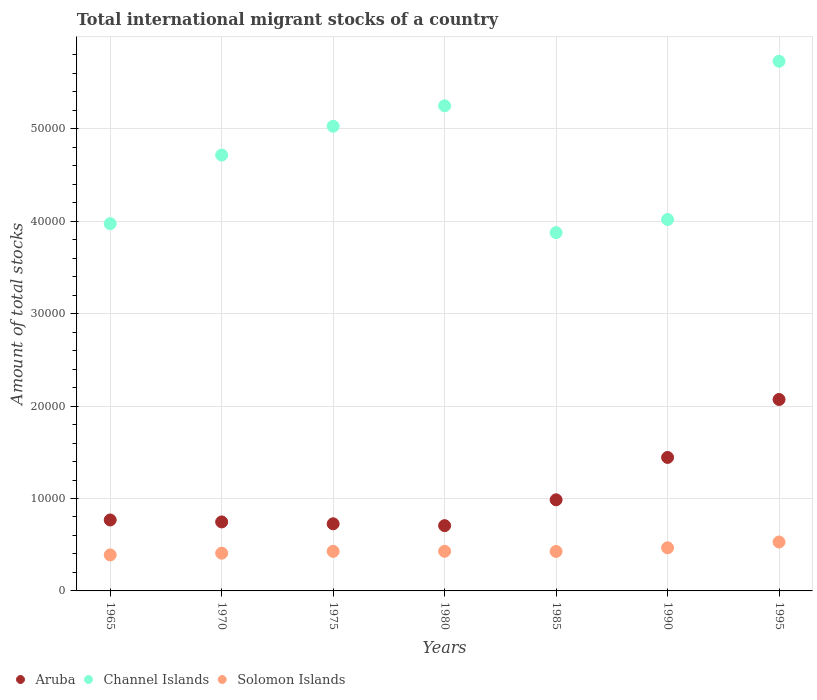How many different coloured dotlines are there?
Keep it short and to the point. 3. What is the amount of total stocks in in Solomon Islands in 1995?
Ensure brevity in your answer.  5293. Across all years, what is the maximum amount of total stocks in in Solomon Islands?
Offer a very short reply. 5293. Across all years, what is the minimum amount of total stocks in in Aruba?
Give a very brief answer. 7063. What is the total amount of total stocks in in Aruba in the graph?
Ensure brevity in your answer.  7.45e+04. What is the difference between the amount of total stocks in in Aruba in 1970 and that in 1990?
Ensure brevity in your answer.  -6978. What is the difference between the amount of total stocks in in Solomon Islands in 1990 and the amount of total stocks in in Aruba in 1965?
Ensure brevity in your answer.  -3009. What is the average amount of total stocks in in Solomon Islands per year?
Provide a short and direct response. 4397.29. In the year 1975, what is the difference between the amount of total stocks in in Aruba and amount of total stocks in in Solomon Islands?
Your answer should be compact. 2980. What is the ratio of the amount of total stocks in in Channel Islands in 1975 to that in 1985?
Offer a very short reply. 1.3. What is the difference between the highest and the second highest amount of total stocks in in Aruba?
Your answer should be very brief. 6271. What is the difference between the highest and the lowest amount of total stocks in in Solomon Islands?
Keep it short and to the point. 1398. In how many years, is the amount of total stocks in in Channel Islands greater than the average amount of total stocks in in Channel Islands taken over all years?
Your answer should be compact. 4. Does the amount of total stocks in in Channel Islands monotonically increase over the years?
Your answer should be very brief. No. Is the amount of total stocks in in Aruba strictly greater than the amount of total stocks in in Solomon Islands over the years?
Give a very brief answer. Yes. How many dotlines are there?
Make the answer very short. 3. Are the values on the major ticks of Y-axis written in scientific E-notation?
Provide a succinct answer. No. Where does the legend appear in the graph?
Your answer should be very brief. Bottom left. How many legend labels are there?
Ensure brevity in your answer.  3. What is the title of the graph?
Offer a very short reply. Total international migrant stocks of a country. Does "South Sudan" appear as one of the legend labels in the graph?
Your answer should be very brief. No. What is the label or title of the X-axis?
Provide a short and direct response. Years. What is the label or title of the Y-axis?
Offer a terse response. Amount of total stocks. What is the Amount of total stocks of Aruba in 1965?
Your answer should be very brief. 7677. What is the Amount of total stocks in Channel Islands in 1965?
Your answer should be compact. 3.97e+04. What is the Amount of total stocks of Solomon Islands in 1965?
Offer a very short reply. 3895. What is the Amount of total stocks in Aruba in 1970?
Offer a very short reply. 7466. What is the Amount of total stocks of Channel Islands in 1970?
Ensure brevity in your answer.  4.72e+04. What is the Amount of total stocks of Solomon Islands in 1970?
Offer a terse response. 4084. What is the Amount of total stocks in Aruba in 1975?
Give a very brief answer. 7262. What is the Amount of total stocks in Channel Islands in 1975?
Make the answer very short. 5.03e+04. What is the Amount of total stocks of Solomon Islands in 1975?
Provide a succinct answer. 4282. What is the Amount of total stocks of Aruba in 1980?
Give a very brief answer. 7063. What is the Amount of total stocks of Channel Islands in 1980?
Make the answer very short. 5.25e+04. What is the Amount of total stocks of Solomon Islands in 1980?
Make the answer very short. 4289. What is the Amount of total stocks of Aruba in 1985?
Make the answer very short. 9860. What is the Amount of total stocks in Channel Islands in 1985?
Give a very brief answer. 3.88e+04. What is the Amount of total stocks in Solomon Islands in 1985?
Offer a very short reply. 4270. What is the Amount of total stocks of Aruba in 1990?
Give a very brief answer. 1.44e+04. What is the Amount of total stocks in Channel Islands in 1990?
Keep it short and to the point. 4.02e+04. What is the Amount of total stocks of Solomon Islands in 1990?
Keep it short and to the point. 4668. What is the Amount of total stocks in Aruba in 1995?
Keep it short and to the point. 2.07e+04. What is the Amount of total stocks of Channel Islands in 1995?
Offer a terse response. 5.73e+04. What is the Amount of total stocks of Solomon Islands in 1995?
Offer a terse response. 5293. Across all years, what is the maximum Amount of total stocks in Aruba?
Give a very brief answer. 2.07e+04. Across all years, what is the maximum Amount of total stocks in Channel Islands?
Make the answer very short. 5.73e+04. Across all years, what is the maximum Amount of total stocks in Solomon Islands?
Give a very brief answer. 5293. Across all years, what is the minimum Amount of total stocks in Aruba?
Offer a terse response. 7063. Across all years, what is the minimum Amount of total stocks in Channel Islands?
Provide a succinct answer. 3.88e+04. Across all years, what is the minimum Amount of total stocks in Solomon Islands?
Ensure brevity in your answer.  3895. What is the total Amount of total stocks of Aruba in the graph?
Your response must be concise. 7.45e+04. What is the total Amount of total stocks in Channel Islands in the graph?
Give a very brief answer. 3.26e+05. What is the total Amount of total stocks in Solomon Islands in the graph?
Offer a terse response. 3.08e+04. What is the difference between the Amount of total stocks of Aruba in 1965 and that in 1970?
Make the answer very short. 211. What is the difference between the Amount of total stocks of Channel Islands in 1965 and that in 1970?
Ensure brevity in your answer.  -7426. What is the difference between the Amount of total stocks in Solomon Islands in 1965 and that in 1970?
Offer a terse response. -189. What is the difference between the Amount of total stocks of Aruba in 1965 and that in 1975?
Your answer should be very brief. 415. What is the difference between the Amount of total stocks of Channel Islands in 1965 and that in 1975?
Keep it short and to the point. -1.05e+04. What is the difference between the Amount of total stocks of Solomon Islands in 1965 and that in 1975?
Your answer should be very brief. -387. What is the difference between the Amount of total stocks in Aruba in 1965 and that in 1980?
Keep it short and to the point. 614. What is the difference between the Amount of total stocks of Channel Islands in 1965 and that in 1980?
Your response must be concise. -1.28e+04. What is the difference between the Amount of total stocks in Solomon Islands in 1965 and that in 1980?
Ensure brevity in your answer.  -394. What is the difference between the Amount of total stocks in Aruba in 1965 and that in 1985?
Ensure brevity in your answer.  -2183. What is the difference between the Amount of total stocks in Channel Islands in 1965 and that in 1985?
Your answer should be compact. 969. What is the difference between the Amount of total stocks of Solomon Islands in 1965 and that in 1985?
Offer a very short reply. -375. What is the difference between the Amount of total stocks in Aruba in 1965 and that in 1990?
Give a very brief answer. -6767. What is the difference between the Amount of total stocks in Channel Islands in 1965 and that in 1990?
Give a very brief answer. -452. What is the difference between the Amount of total stocks in Solomon Islands in 1965 and that in 1990?
Your answer should be very brief. -773. What is the difference between the Amount of total stocks in Aruba in 1965 and that in 1995?
Provide a succinct answer. -1.30e+04. What is the difference between the Amount of total stocks of Channel Islands in 1965 and that in 1995?
Offer a very short reply. -1.76e+04. What is the difference between the Amount of total stocks of Solomon Islands in 1965 and that in 1995?
Make the answer very short. -1398. What is the difference between the Amount of total stocks of Aruba in 1970 and that in 1975?
Offer a very short reply. 204. What is the difference between the Amount of total stocks of Channel Islands in 1970 and that in 1975?
Make the answer very short. -3115. What is the difference between the Amount of total stocks in Solomon Islands in 1970 and that in 1975?
Make the answer very short. -198. What is the difference between the Amount of total stocks of Aruba in 1970 and that in 1980?
Ensure brevity in your answer.  403. What is the difference between the Amount of total stocks in Channel Islands in 1970 and that in 1980?
Offer a terse response. -5328. What is the difference between the Amount of total stocks of Solomon Islands in 1970 and that in 1980?
Offer a very short reply. -205. What is the difference between the Amount of total stocks in Aruba in 1970 and that in 1985?
Give a very brief answer. -2394. What is the difference between the Amount of total stocks of Channel Islands in 1970 and that in 1985?
Make the answer very short. 8395. What is the difference between the Amount of total stocks of Solomon Islands in 1970 and that in 1985?
Give a very brief answer. -186. What is the difference between the Amount of total stocks of Aruba in 1970 and that in 1990?
Make the answer very short. -6978. What is the difference between the Amount of total stocks of Channel Islands in 1970 and that in 1990?
Keep it short and to the point. 6974. What is the difference between the Amount of total stocks in Solomon Islands in 1970 and that in 1990?
Your answer should be very brief. -584. What is the difference between the Amount of total stocks of Aruba in 1970 and that in 1995?
Offer a very short reply. -1.32e+04. What is the difference between the Amount of total stocks in Channel Islands in 1970 and that in 1995?
Ensure brevity in your answer.  -1.01e+04. What is the difference between the Amount of total stocks of Solomon Islands in 1970 and that in 1995?
Ensure brevity in your answer.  -1209. What is the difference between the Amount of total stocks of Aruba in 1975 and that in 1980?
Ensure brevity in your answer.  199. What is the difference between the Amount of total stocks in Channel Islands in 1975 and that in 1980?
Offer a very short reply. -2213. What is the difference between the Amount of total stocks of Solomon Islands in 1975 and that in 1980?
Offer a very short reply. -7. What is the difference between the Amount of total stocks of Aruba in 1975 and that in 1985?
Provide a succinct answer. -2598. What is the difference between the Amount of total stocks of Channel Islands in 1975 and that in 1985?
Offer a very short reply. 1.15e+04. What is the difference between the Amount of total stocks of Solomon Islands in 1975 and that in 1985?
Your answer should be compact. 12. What is the difference between the Amount of total stocks in Aruba in 1975 and that in 1990?
Provide a succinct answer. -7182. What is the difference between the Amount of total stocks in Channel Islands in 1975 and that in 1990?
Your answer should be compact. 1.01e+04. What is the difference between the Amount of total stocks of Solomon Islands in 1975 and that in 1990?
Your answer should be very brief. -386. What is the difference between the Amount of total stocks of Aruba in 1975 and that in 1995?
Provide a succinct answer. -1.35e+04. What is the difference between the Amount of total stocks of Channel Islands in 1975 and that in 1995?
Make the answer very short. -7033. What is the difference between the Amount of total stocks in Solomon Islands in 1975 and that in 1995?
Make the answer very short. -1011. What is the difference between the Amount of total stocks of Aruba in 1980 and that in 1985?
Ensure brevity in your answer.  -2797. What is the difference between the Amount of total stocks in Channel Islands in 1980 and that in 1985?
Make the answer very short. 1.37e+04. What is the difference between the Amount of total stocks of Aruba in 1980 and that in 1990?
Offer a terse response. -7381. What is the difference between the Amount of total stocks of Channel Islands in 1980 and that in 1990?
Your answer should be compact. 1.23e+04. What is the difference between the Amount of total stocks of Solomon Islands in 1980 and that in 1990?
Ensure brevity in your answer.  -379. What is the difference between the Amount of total stocks in Aruba in 1980 and that in 1995?
Give a very brief answer. -1.37e+04. What is the difference between the Amount of total stocks of Channel Islands in 1980 and that in 1995?
Make the answer very short. -4820. What is the difference between the Amount of total stocks of Solomon Islands in 1980 and that in 1995?
Your answer should be compact. -1004. What is the difference between the Amount of total stocks of Aruba in 1985 and that in 1990?
Provide a short and direct response. -4584. What is the difference between the Amount of total stocks in Channel Islands in 1985 and that in 1990?
Ensure brevity in your answer.  -1421. What is the difference between the Amount of total stocks in Solomon Islands in 1985 and that in 1990?
Your answer should be very brief. -398. What is the difference between the Amount of total stocks of Aruba in 1985 and that in 1995?
Keep it short and to the point. -1.09e+04. What is the difference between the Amount of total stocks of Channel Islands in 1985 and that in 1995?
Provide a short and direct response. -1.85e+04. What is the difference between the Amount of total stocks in Solomon Islands in 1985 and that in 1995?
Your answer should be compact. -1023. What is the difference between the Amount of total stocks of Aruba in 1990 and that in 1995?
Make the answer very short. -6271. What is the difference between the Amount of total stocks of Channel Islands in 1990 and that in 1995?
Ensure brevity in your answer.  -1.71e+04. What is the difference between the Amount of total stocks in Solomon Islands in 1990 and that in 1995?
Give a very brief answer. -625. What is the difference between the Amount of total stocks in Aruba in 1965 and the Amount of total stocks in Channel Islands in 1970?
Your answer should be very brief. -3.95e+04. What is the difference between the Amount of total stocks in Aruba in 1965 and the Amount of total stocks in Solomon Islands in 1970?
Your answer should be compact. 3593. What is the difference between the Amount of total stocks of Channel Islands in 1965 and the Amount of total stocks of Solomon Islands in 1970?
Your answer should be very brief. 3.57e+04. What is the difference between the Amount of total stocks in Aruba in 1965 and the Amount of total stocks in Channel Islands in 1975?
Ensure brevity in your answer.  -4.26e+04. What is the difference between the Amount of total stocks in Aruba in 1965 and the Amount of total stocks in Solomon Islands in 1975?
Offer a very short reply. 3395. What is the difference between the Amount of total stocks of Channel Islands in 1965 and the Amount of total stocks of Solomon Islands in 1975?
Your answer should be very brief. 3.55e+04. What is the difference between the Amount of total stocks of Aruba in 1965 and the Amount of total stocks of Channel Islands in 1980?
Ensure brevity in your answer.  -4.48e+04. What is the difference between the Amount of total stocks in Aruba in 1965 and the Amount of total stocks in Solomon Islands in 1980?
Make the answer very short. 3388. What is the difference between the Amount of total stocks of Channel Islands in 1965 and the Amount of total stocks of Solomon Islands in 1980?
Provide a short and direct response. 3.54e+04. What is the difference between the Amount of total stocks in Aruba in 1965 and the Amount of total stocks in Channel Islands in 1985?
Your answer should be very brief. -3.11e+04. What is the difference between the Amount of total stocks in Aruba in 1965 and the Amount of total stocks in Solomon Islands in 1985?
Make the answer very short. 3407. What is the difference between the Amount of total stocks in Channel Islands in 1965 and the Amount of total stocks in Solomon Islands in 1985?
Provide a short and direct response. 3.55e+04. What is the difference between the Amount of total stocks of Aruba in 1965 and the Amount of total stocks of Channel Islands in 1990?
Make the answer very short. -3.25e+04. What is the difference between the Amount of total stocks in Aruba in 1965 and the Amount of total stocks in Solomon Islands in 1990?
Provide a succinct answer. 3009. What is the difference between the Amount of total stocks of Channel Islands in 1965 and the Amount of total stocks of Solomon Islands in 1990?
Offer a very short reply. 3.51e+04. What is the difference between the Amount of total stocks in Aruba in 1965 and the Amount of total stocks in Channel Islands in 1995?
Make the answer very short. -4.96e+04. What is the difference between the Amount of total stocks of Aruba in 1965 and the Amount of total stocks of Solomon Islands in 1995?
Your response must be concise. 2384. What is the difference between the Amount of total stocks of Channel Islands in 1965 and the Amount of total stocks of Solomon Islands in 1995?
Offer a very short reply. 3.44e+04. What is the difference between the Amount of total stocks in Aruba in 1970 and the Amount of total stocks in Channel Islands in 1975?
Your response must be concise. -4.28e+04. What is the difference between the Amount of total stocks of Aruba in 1970 and the Amount of total stocks of Solomon Islands in 1975?
Provide a short and direct response. 3184. What is the difference between the Amount of total stocks in Channel Islands in 1970 and the Amount of total stocks in Solomon Islands in 1975?
Offer a very short reply. 4.29e+04. What is the difference between the Amount of total stocks in Aruba in 1970 and the Amount of total stocks in Channel Islands in 1980?
Give a very brief answer. -4.50e+04. What is the difference between the Amount of total stocks in Aruba in 1970 and the Amount of total stocks in Solomon Islands in 1980?
Your response must be concise. 3177. What is the difference between the Amount of total stocks in Channel Islands in 1970 and the Amount of total stocks in Solomon Islands in 1980?
Make the answer very short. 4.29e+04. What is the difference between the Amount of total stocks of Aruba in 1970 and the Amount of total stocks of Channel Islands in 1985?
Provide a short and direct response. -3.13e+04. What is the difference between the Amount of total stocks of Aruba in 1970 and the Amount of total stocks of Solomon Islands in 1985?
Your response must be concise. 3196. What is the difference between the Amount of total stocks of Channel Islands in 1970 and the Amount of total stocks of Solomon Islands in 1985?
Your answer should be compact. 4.29e+04. What is the difference between the Amount of total stocks in Aruba in 1970 and the Amount of total stocks in Channel Islands in 1990?
Make the answer very short. -3.27e+04. What is the difference between the Amount of total stocks of Aruba in 1970 and the Amount of total stocks of Solomon Islands in 1990?
Your answer should be compact. 2798. What is the difference between the Amount of total stocks in Channel Islands in 1970 and the Amount of total stocks in Solomon Islands in 1990?
Ensure brevity in your answer.  4.25e+04. What is the difference between the Amount of total stocks of Aruba in 1970 and the Amount of total stocks of Channel Islands in 1995?
Provide a succinct answer. -4.98e+04. What is the difference between the Amount of total stocks of Aruba in 1970 and the Amount of total stocks of Solomon Islands in 1995?
Offer a terse response. 2173. What is the difference between the Amount of total stocks in Channel Islands in 1970 and the Amount of total stocks in Solomon Islands in 1995?
Give a very brief answer. 4.19e+04. What is the difference between the Amount of total stocks in Aruba in 1975 and the Amount of total stocks in Channel Islands in 1980?
Provide a succinct answer. -4.52e+04. What is the difference between the Amount of total stocks of Aruba in 1975 and the Amount of total stocks of Solomon Islands in 1980?
Your answer should be very brief. 2973. What is the difference between the Amount of total stocks in Channel Islands in 1975 and the Amount of total stocks in Solomon Islands in 1980?
Offer a terse response. 4.60e+04. What is the difference between the Amount of total stocks of Aruba in 1975 and the Amount of total stocks of Channel Islands in 1985?
Keep it short and to the point. -3.15e+04. What is the difference between the Amount of total stocks of Aruba in 1975 and the Amount of total stocks of Solomon Islands in 1985?
Offer a very short reply. 2992. What is the difference between the Amount of total stocks in Channel Islands in 1975 and the Amount of total stocks in Solomon Islands in 1985?
Provide a succinct answer. 4.60e+04. What is the difference between the Amount of total stocks in Aruba in 1975 and the Amount of total stocks in Channel Islands in 1990?
Make the answer very short. -3.29e+04. What is the difference between the Amount of total stocks in Aruba in 1975 and the Amount of total stocks in Solomon Islands in 1990?
Offer a very short reply. 2594. What is the difference between the Amount of total stocks in Channel Islands in 1975 and the Amount of total stocks in Solomon Islands in 1990?
Make the answer very short. 4.56e+04. What is the difference between the Amount of total stocks in Aruba in 1975 and the Amount of total stocks in Channel Islands in 1995?
Offer a terse response. -5.01e+04. What is the difference between the Amount of total stocks in Aruba in 1975 and the Amount of total stocks in Solomon Islands in 1995?
Your answer should be very brief. 1969. What is the difference between the Amount of total stocks of Channel Islands in 1975 and the Amount of total stocks of Solomon Islands in 1995?
Your answer should be compact. 4.50e+04. What is the difference between the Amount of total stocks in Aruba in 1980 and the Amount of total stocks in Channel Islands in 1985?
Ensure brevity in your answer.  -3.17e+04. What is the difference between the Amount of total stocks of Aruba in 1980 and the Amount of total stocks of Solomon Islands in 1985?
Offer a terse response. 2793. What is the difference between the Amount of total stocks in Channel Islands in 1980 and the Amount of total stocks in Solomon Islands in 1985?
Provide a short and direct response. 4.82e+04. What is the difference between the Amount of total stocks in Aruba in 1980 and the Amount of total stocks in Channel Islands in 1990?
Your response must be concise. -3.31e+04. What is the difference between the Amount of total stocks of Aruba in 1980 and the Amount of total stocks of Solomon Islands in 1990?
Provide a succinct answer. 2395. What is the difference between the Amount of total stocks in Channel Islands in 1980 and the Amount of total stocks in Solomon Islands in 1990?
Make the answer very short. 4.78e+04. What is the difference between the Amount of total stocks of Aruba in 1980 and the Amount of total stocks of Channel Islands in 1995?
Keep it short and to the point. -5.02e+04. What is the difference between the Amount of total stocks in Aruba in 1980 and the Amount of total stocks in Solomon Islands in 1995?
Offer a very short reply. 1770. What is the difference between the Amount of total stocks in Channel Islands in 1980 and the Amount of total stocks in Solomon Islands in 1995?
Your response must be concise. 4.72e+04. What is the difference between the Amount of total stocks of Aruba in 1985 and the Amount of total stocks of Channel Islands in 1990?
Keep it short and to the point. -3.03e+04. What is the difference between the Amount of total stocks of Aruba in 1985 and the Amount of total stocks of Solomon Islands in 1990?
Give a very brief answer. 5192. What is the difference between the Amount of total stocks in Channel Islands in 1985 and the Amount of total stocks in Solomon Islands in 1990?
Your response must be concise. 3.41e+04. What is the difference between the Amount of total stocks of Aruba in 1985 and the Amount of total stocks of Channel Islands in 1995?
Offer a very short reply. -4.75e+04. What is the difference between the Amount of total stocks of Aruba in 1985 and the Amount of total stocks of Solomon Islands in 1995?
Offer a terse response. 4567. What is the difference between the Amount of total stocks in Channel Islands in 1985 and the Amount of total stocks in Solomon Islands in 1995?
Make the answer very short. 3.35e+04. What is the difference between the Amount of total stocks of Aruba in 1990 and the Amount of total stocks of Channel Islands in 1995?
Provide a succinct answer. -4.29e+04. What is the difference between the Amount of total stocks of Aruba in 1990 and the Amount of total stocks of Solomon Islands in 1995?
Ensure brevity in your answer.  9151. What is the difference between the Amount of total stocks of Channel Islands in 1990 and the Amount of total stocks of Solomon Islands in 1995?
Your response must be concise. 3.49e+04. What is the average Amount of total stocks of Aruba per year?
Offer a very short reply. 1.06e+04. What is the average Amount of total stocks of Channel Islands per year?
Your response must be concise. 4.66e+04. What is the average Amount of total stocks in Solomon Islands per year?
Keep it short and to the point. 4397.29. In the year 1965, what is the difference between the Amount of total stocks of Aruba and Amount of total stocks of Channel Islands?
Your answer should be very brief. -3.21e+04. In the year 1965, what is the difference between the Amount of total stocks in Aruba and Amount of total stocks in Solomon Islands?
Ensure brevity in your answer.  3782. In the year 1965, what is the difference between the Amount of total stocks of Channel Islands and Amount of total stocks of Solomon Islands?
Your answer should be compact. 3.58e+04. In the year 1970, what is the difference between the Amount of total stocks in Aruba and Amount of total stocks in Channel Islands?
Make the answer very short. -3.97e+04. In the year 1970, what is the difference between the Amount of total stocks in Aruba and Amount of total stocks in Solomon Islands?
Provide a short and direct response. 3382. In the year 1970, what is the difference between the Amount of total stocks of Channel Islands and Amount of total stocks of Solomon Islands?
Your response must be concise. 4.31e+04. In the year 1975, what is the difference between the Amount of total stocks in Aruba and Amount of total stocks in Channel Islands?
Offer a terse response. -4.30e+04. In the year 1975, what is the difference between the Amount of total stocks of Aruba and Amount of total stocks of Solomon Islands?
Your answer should be very brief. 2980. In the year 1975, what is the difference between the Amount of total stocks in Channel Islands and Amount of total stocks in Solomon Islands?
Your response must be concise. 4.60e+04. In the year 1980, what is the difference between the Amount of total stocks of Aruba and Amount of total stocks of Channel Islands?
Give a very brief answer. -4.54e+04. In the year 1980, what is the difference between the Amount of total stocks of Aruba and Amount of total stocks of Solomon Islands?
Provide a short and direct response. 2774. In the year 1980, what is the difference between the Amount of total stocks in Channel Islands and Amount of total stocks in Solomon Islands?
Give a very brief answer. 4.82e+04. In the year 1985, what is the difference between the Amount of total stocks in Aruba and Amount of total stocks in Channel Islands?
Provide a succinct answer. -2.89e+04. In the year 1985, what is the difference between the Amount of total stocks of Aruba and Amount of total stocks of Solomon Islands?
Your answer should be very brief. 5590. In the year 1985, what is the difference between the Amount of total stocks in Channel Islands and Amount of total stocks in Solomon Islands?
Make the answer very short. 3.45e+04. In the year 1990, what is the difference between the Amount of total stocks of Aruba and Amount of total stocks of Channel Islands?
Give a very brief answer. -2.57e+04. In the year 1990, what is the difference between the Amount of total stocks in Aruba and Amount of total stocks in Solomon Islands?
Your answer should be very brief. 9776. In the year 1990, what is the difference between the Amount of total stocks of Channel Islands and Amount of total stocks of Solomon Islands?
Make the answer very short. 3.55e+04. In the year 1995, what is the difference between the Amount of total stocks in Aruba and Amount of total stocks in Channel Islands?
Provide a succinct answer. -3.66e+04. In the year 1995, what is the difference between the Amount of total stocks of Aruba and Amount of total stocks of Solomon Islands?
Your answer should be very brief. 1.54e+04. In the year 1995, what is the difference between the Amount of total stocks in Channel Islands and Amount of total stocks in Solomon Islands?
Give a very brief answer. 5.20e+04. What is the ratio of the Amount of total stocks in Aruba in 1965 to that in 1970?
Offer a terse response. 1.03. What is the ratio of the Amount of total stocks in Channel Islands in 1965 to that in 1970?
Keep it short and to the point. 0.84. What is the ratio of the Amount of total stocks in Solomon Islands in 1965 to that in 1970?
Your response must be concise. 0.95. What is the ratio of the Amount of total stocks in Aruba in 1965 to that in 1975?
Your response must be concise. 1.06. What is the ratio of the Amount of total stocks of Channel Islands in 1965 to that in 1975?
Provide a succinct answer. 0.79. What is the ratio of the Amount of total stocks in Solomon Islands in 1965 to that in 1975?
Your answer should be very brief. 0.91. What is the ratio of the Amount of total stocks in Aruba in 1965 to that in 1980?
Your answer should be very brief. 1.09. What is the ratio of the Amount of total stocks of Channel Islands in 1965 to that in 1980?
Make the answer very short. 0.76. What is the ratio of the Amount of total stocks of Solomon Islands in 1965 to that in 1980?
Keep it short and to the point. 0.91. What is the ratio of the Amount of total stocks of Aruba in 1965 to that in 1985?
Provide a succinct answer. 0.78. What is the ratio of the Amount of total stocks in Solomon Islands in 1965 to that in 1985?
Make the answer very short. 0.91. What is the ratio of the Amount of total stocks of Aruba in 1965 to that in 1990?
Your answer should be compact. 0.53. What is the ratio of the Amount of total stocks of Channel Islands in 1965 to that in 1990?
Make the answer very short. 0.99. What is the ratio of the Amount of total stocks of Solomon Islands in 1965 to that in 1990?
Ensure brevity in your answer.  0.83. What is the ratio of the Amount of total stocks of Aruba in 1965 to that in 1995?
Give a very brief answer. 0.37. What is the ratio of the Amount of total stocks in Channel Islands in 1965 to that in 1995?
Make the answer very short. 0.69. What is the ratio of the Amount of total stocks in Solomon Islands in 1965 to that in 1995?
Provide a succinct answer. 0.74. What is the ratio of the Amount of total stocks in Aruba in 1970 to that in 1975?
Provide a succinct answer. 1.03. What is the ratio of the Amount of total stocks of Channel Islands in 1970 to that in 1975?
Offer a terse response. 0.94. What is the ratio of the Amount of total stocks in Solomon Islands in 1970 to that in 1975?
Keep it short and to the point. 0.95. What is the ratio of the Amount of total stocks in Aruba in 1970 to that in 1980?
Keep it short and to the point. 1.06. What is the ratio of the Amount of total stocks of Channel Islands in 1970 to that in 1980?
Provide a short and direct response. 0.9. What is the ratio of the Amount of total stocks of Solomon Islands in 1970 to that in 1980?
Give a very brief answer. 0.95. What is the ratio of the Amount of total stocks in Aruba in 1970 to that in 1985?
Provide a short and direct response. 0.76. What is the ratio of the Amount of total stocks of Channel Islands in 1970 to that in 1985?
Provide a short and direct response. 1.22. What is the ratio of the Amount of total stocks in Solomon Islands in 1970 to that in 1985?
Give a very brief answer. 0.96. What is the ratio of the Amount of total stocks in Aruba in 1970 to that in 1990?
Ensure brevity in your answer.  0.52. What is the ratio of the Amount of total stocks in Channel Islands in 1970 to that in 1990?
Give a very brief answer. 1.17. What is the ratio of the Amount of total stocks of Solomon Islands in 1970 to that in 1990?
Offer a terse response. 0.87. What is the ratio of the Amount of total stocks of Aruba in 1970 to that in 1995?
Your answer should be very brief. 0.36. What is the ratio of the Amount of total stocks of Channel Islands in 1970 to that in 1995?
Provide a succinct answer. 0.82. What is the ratio of the Amount of total stocks of Solomon Islands in 1970 to that in 1995?
Give a very brief answer. 0.77. What is the ratio of the Amount of total stocks of Aruba in 1975 to that in 1980?
Make the answer very short. 1.03. What is the ratio of the Amount of total stocks of Channel Islands in 1975 to that in 1980?
Your answer should be compact. 0.96. What is the ratio of the Amount of total stocks of Solomon Islands in 1975 to that in 1980?
Offer a terse response. 1. What is the ratio of the Amount of total stocks in Aruba in 1975 to that in 1985?
Give a very brief answer. 0.74. What is the ratio of the Amount of total stocks of Channel Islands in 1975 to that in 1985?
Provide a succinct answer. 1.3. What is the ratio of the Amount of total stocks in Solomon Islands in 1975 to that in 1985?
Your answer should be very brief. 1. What is the ratio of the Amount of total stocks of Aruba in 1975 to that in 1990?
Offer a very short reply. 0.5. What is the ratio of the Amount of total stocks of Channel Islands in 1975 to that in 1990?
Your answer should be very brief. 1.25. What is the ratio of the Amount of total stocks of Solomon Islands in 1975 to that in 1990?
Offer a terse response. 0.92. What is the ratio of the Amount of total stocks of Aruba in 1975 to that in 1995?
Ensure brevity in your answer.  0.35. What is the ratio of the Amount of total stocks of Channel Islands in 1975 to that in 1995?
Give a very brief answer. 0.88. What is the ratio of the Amount of total stocks in Solomon Islands in 1975 to that in 1995?
Make the answer very short. 0.81. What is the ratio of the Amount of total stocks of Aruba in 1980 to that in 1985?
Give a very brief answer. 0.72. What is the ratio of the Amount of total stocks of Channel Islands in 1980 to that in 1985?
Provide a short and direct response. 1.35. What is the ratio of the Amount of total stocks in Solomon Islands in 1980 to that in 1985?
Give a very brief answer. 1. What is the ratio of the Amount of total stocks of Aruba in 1980 to that in 1990?
Keep it short and to the point. 0.49. What is the ratio of the Amount of total stocks of Channel Islands in 1980 to that in 1990?
Keep it short and to the point. 1.31. What is the ratio of the Amount of total stocks in Solomon Islands in 1980 to that in 1990?
Give a very brief answer. 0.92. What is the ratio of the Amount of total stocks of Aruba in 1980 to that in 1995?
Ensure brevity in your answer.  0.34. What is the ratio of the Amount of total stocks of Channel Islands in 1980 to that in 1995?
Ensure brevity in your answer.  0.92. What is the ratio of the Amount of total stocks of Solomon Islands in 1980 to that in 1995?
Provide a succinct answer. 0.81. What is the ratio of the Amount of total stocks of Aruba in 1985 to that in 1990?
Your answer should be very brief. 0.68. What is the ratio of the Amount of total stocks of Channel Islands in 1985 to that in 1990?
Provide a short and direct response. 0.96. What is the ratio of the Amount of total stocks in Solomon Islands in 1985 to that in 1990?
Offer a terse response. 0.91. What is the ratio of the Amount of total stocks in Aruba in 1985 to that in 1995?
Your response must be concise. 0.48. What is the ratio of the Amount of total stocks in Channel Islands in 1985 to that in 1995?
Keep it short and to the point. 0.68. What is the ratio of the Amount of total stocks of Solomon Islands in 1985 to that in 1995?
Your answer should be compact. 0.81. What is the ratio of the Amount of total stocks of Aruba in 1990 to that in 1995?
Your response must be concise. 0.7. What is the ratio of the Amount of total stocks of Channel Islands in 1990 to that in 1995?
Make the answer very short. 0.7. What is the ratio of the Amount of total stocks of Solomon Islands in 1990 to that in 1995?
Make the answer very short. 0.88. What is the difference between the highest and the second highest Amount of total stocks of Aruba?
Your answer should be compact. 6271. What is the difference between the highest and the second highest Amount of total stocks of Channel Islands?
Offer a very short reply. 4820. What is the difference between the highest and the second highest Amount of total stocks in Solomon Islands?
Your answer should be compact. 625. What is the difference between the highest and the lowest Amount of total stocks of Aruba?
Keep it short and to the point. 1.37e+04. What is the difference between the highest and the lowest Amount of total stocks of Channel Islands?
Ensure brevity in your answer.  1.85e+04. What is the difference between the highest and the lowest Amount of total stocks in Solomon Islands?
Offer a terse response. 1398. 